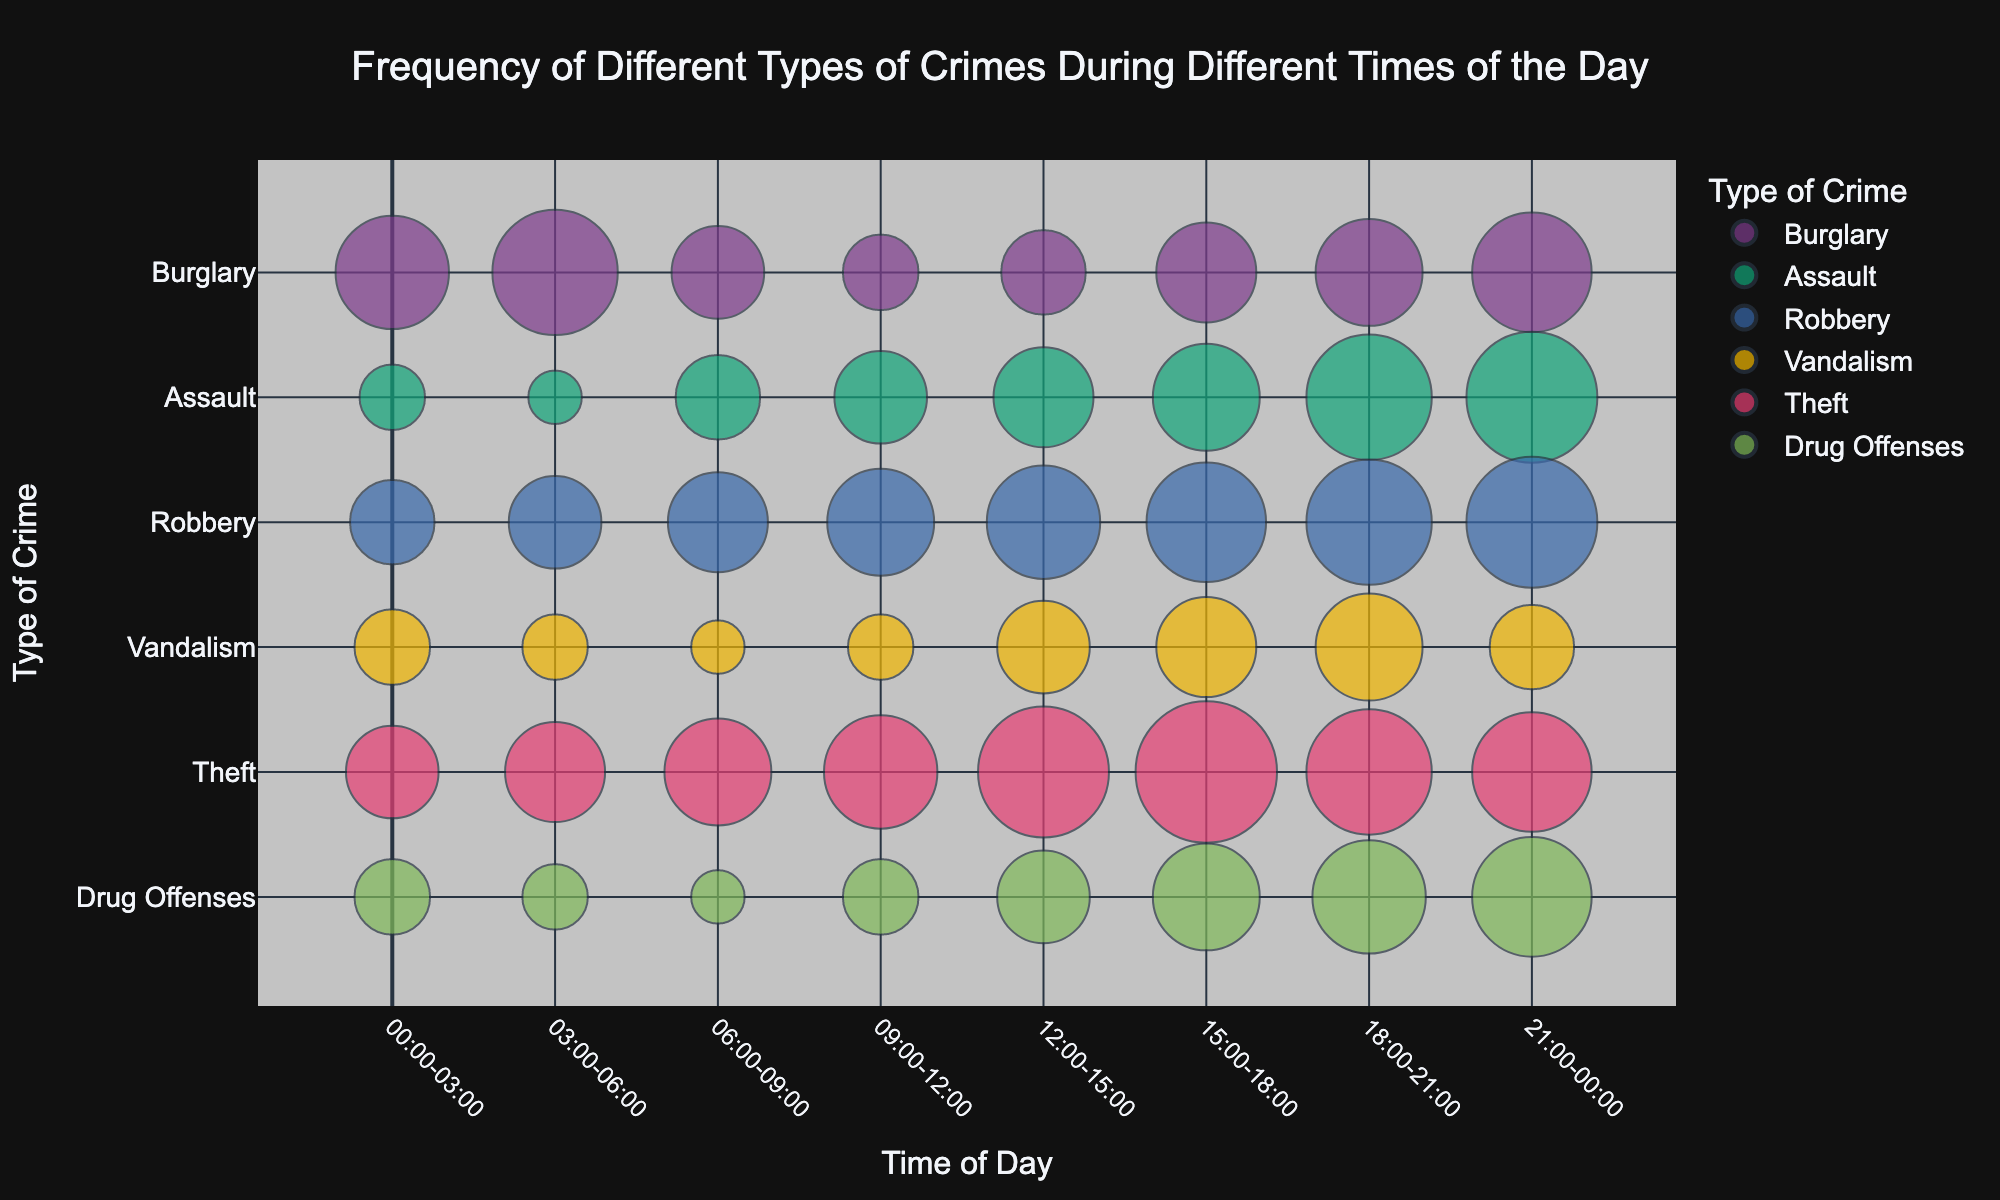What is the title of the chart? The title is usually located at the top of the chart, and it provides a summary of what the chart is about. By looking at the top of the chart, we can see the title "Frequency of Different Types of Crimes During Different Times of the Day."
Answer: Frequency of Different Types of Crimes During Different Times of the Day What does the color of the bubbles represent? In a bubble chart with different colors, the color usually represents different categories. Here, each color represents a different type of crime, such as Burglary, Assault, Robbery, Vandalism, Theft, and Drug Offenses.
Answer: Type of Crime At what time is Theft most frequent? To find when Theft is most frequent, look for the largest bubble corresponding to Theft. The largest bubble for Theft is between 15:00-18:00.
Answer: 15:00-18:00 How do the frequencies of Vandalism between 00:00-03:00 and 09:00-12:00 compare? Comparing the sizes of the bubbles in these two time slots (00:00-03:00 and 09:00-12:00) for Vandalism, we can see that the bubble at 00:00-03:00 is larger. The frequencies are 20 and 15, respectively.
Answer: 20 is greater than 15 What is the total frequency of Drug Offenses during daylight hours (06:00-18:00)? To find the total frequency during daylight hours, sum the frequencies for the time periods 06:00-09:00, 09:00-12:00, 12:00-15:00, and 15:00-18:00, which are 10, 20, 30, and 40 respectively. 10 + 20 + 30 + 40 = 100.
Answer: 100 How does the frequency of Burglary at 00:00-03:00 compare to 21:00-00:00? Observing the size of bubbles for Burglary in these two periods, we can see that the sizes are similar. The frequency at 00:00-03:00 is 45, while at 21:00-00:00 it is 50.
Answer: 50 is greater than 45 What time period has the highest combined frequency for all crime types? Summing the frequencies for all crime types in each time period, we find that the highest total frequency occurs at 21:00-00:00. Adding all crime frequencies in this period: 50 (Burglary) + 60 (Assault) + 60 (Robbery) + 25 (Vandalism) + 50 (Theft) + 50 (Drug Offenses). 50 + 60 + 60 + 25 + 50 + 50 = 295.
Answer: 21:00-00:00 What is the least frequent CrimeType during 03:00-06:00? Looking at the smallest bubble in the 03:00-06:00 time slot, Vandalism has the smallest size with a frequency of 15.
Answer: Vandalism What are the two time periods with the lowest frequency of Assault? To identify the period, compare the sizes of bubbles representing Assault over all time slots. The time periods with the lowest frequencies for Assault are 00:00-03:00 and 03:00-06:00, with frequencies of 15 and 10 respectively.
Answer: 00:00-03:00 and 03:00-06:00 How does the trend in frequency for Robbery change throughout the day? By observing the sequence of bubble sizes for Robbery across all the time slots, the frequency increases from 00:00-03:00 to 21:00-00:00. This indicates that Robbery incidents rise steadily throughout the day, peaking at 60 between 21:00-00:00.
Answer: Increases throughout the day 